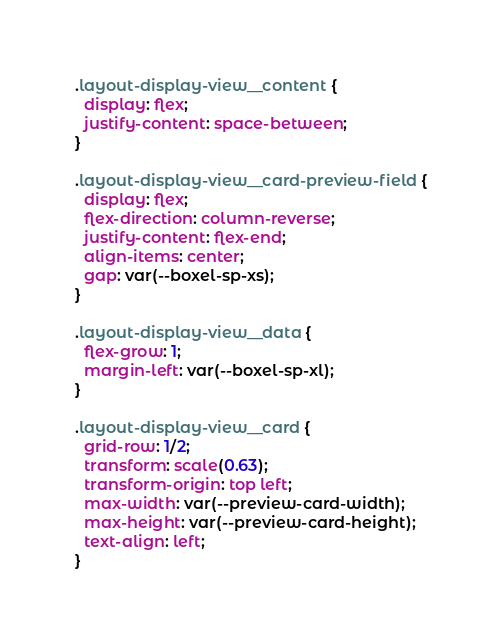<code> <loc_0><loc_0><loc_500><loc_500><_CSS_>.layout-display-view__content {
  display: flex;
  justify-content: space-between;
}

.layout-display-view__card-preview-field {
  display: flex;
  flex-direction: column-reverse;
  justify-content: flex-end;
  align-items: center;
  gap: var(--boxel-sp-xs);
}

.layout-display-view__data {
  flex-grow: 1;
  margin-left: var(--boxel-sp-xl);
}

.layout-display-view__card {
  grid-row: 1/2;
  transform: scale(0.63);
  transform-origin: top left;
  max-width: var(--preview-card-width);
  max-height: var(--preview-card-height);
  text-align: left;
}
</code> 